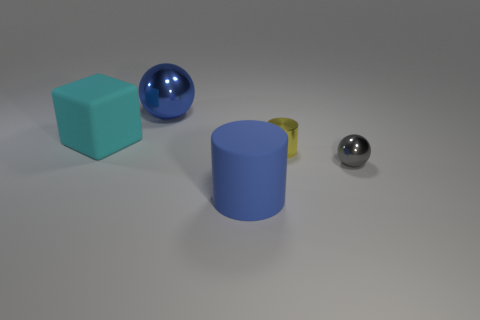Are there any large blue matte objects on the right side of the blue shiny object?
Make the answer very short. Yes. Is there another green block that has the same material as the big block?
Your response must be concise. No. There is a object that is the same color as the big cylinder; what is its size?
Provide a succinct answer. Large. What number of cylinders are either objects or large purple shiny objects?
Provide a short and direct response. 2. Are there more large cylinders that are behind the gray metal thing than gray shiny objects to the left of the big blue cylinder?
Offer a terse response. No. What number of objects have the same color as the tiny shiny sphere?
Offer a very short reply. 0. What size is the gray ball that is the same material as the large blue ball?
Your answer should be compact. Small. How many objects are large metallic objects that are left of the gray shiny ball or green rubber blocks?
Your answer should be compact. 1. Do the sphere behind the gray object and the small shiny cylinder have the same color?
Your response must be concise. No. There is another metallic object that is the same shape as the blue shiny thing; what is its size?
Offer a very short reply. Small. 